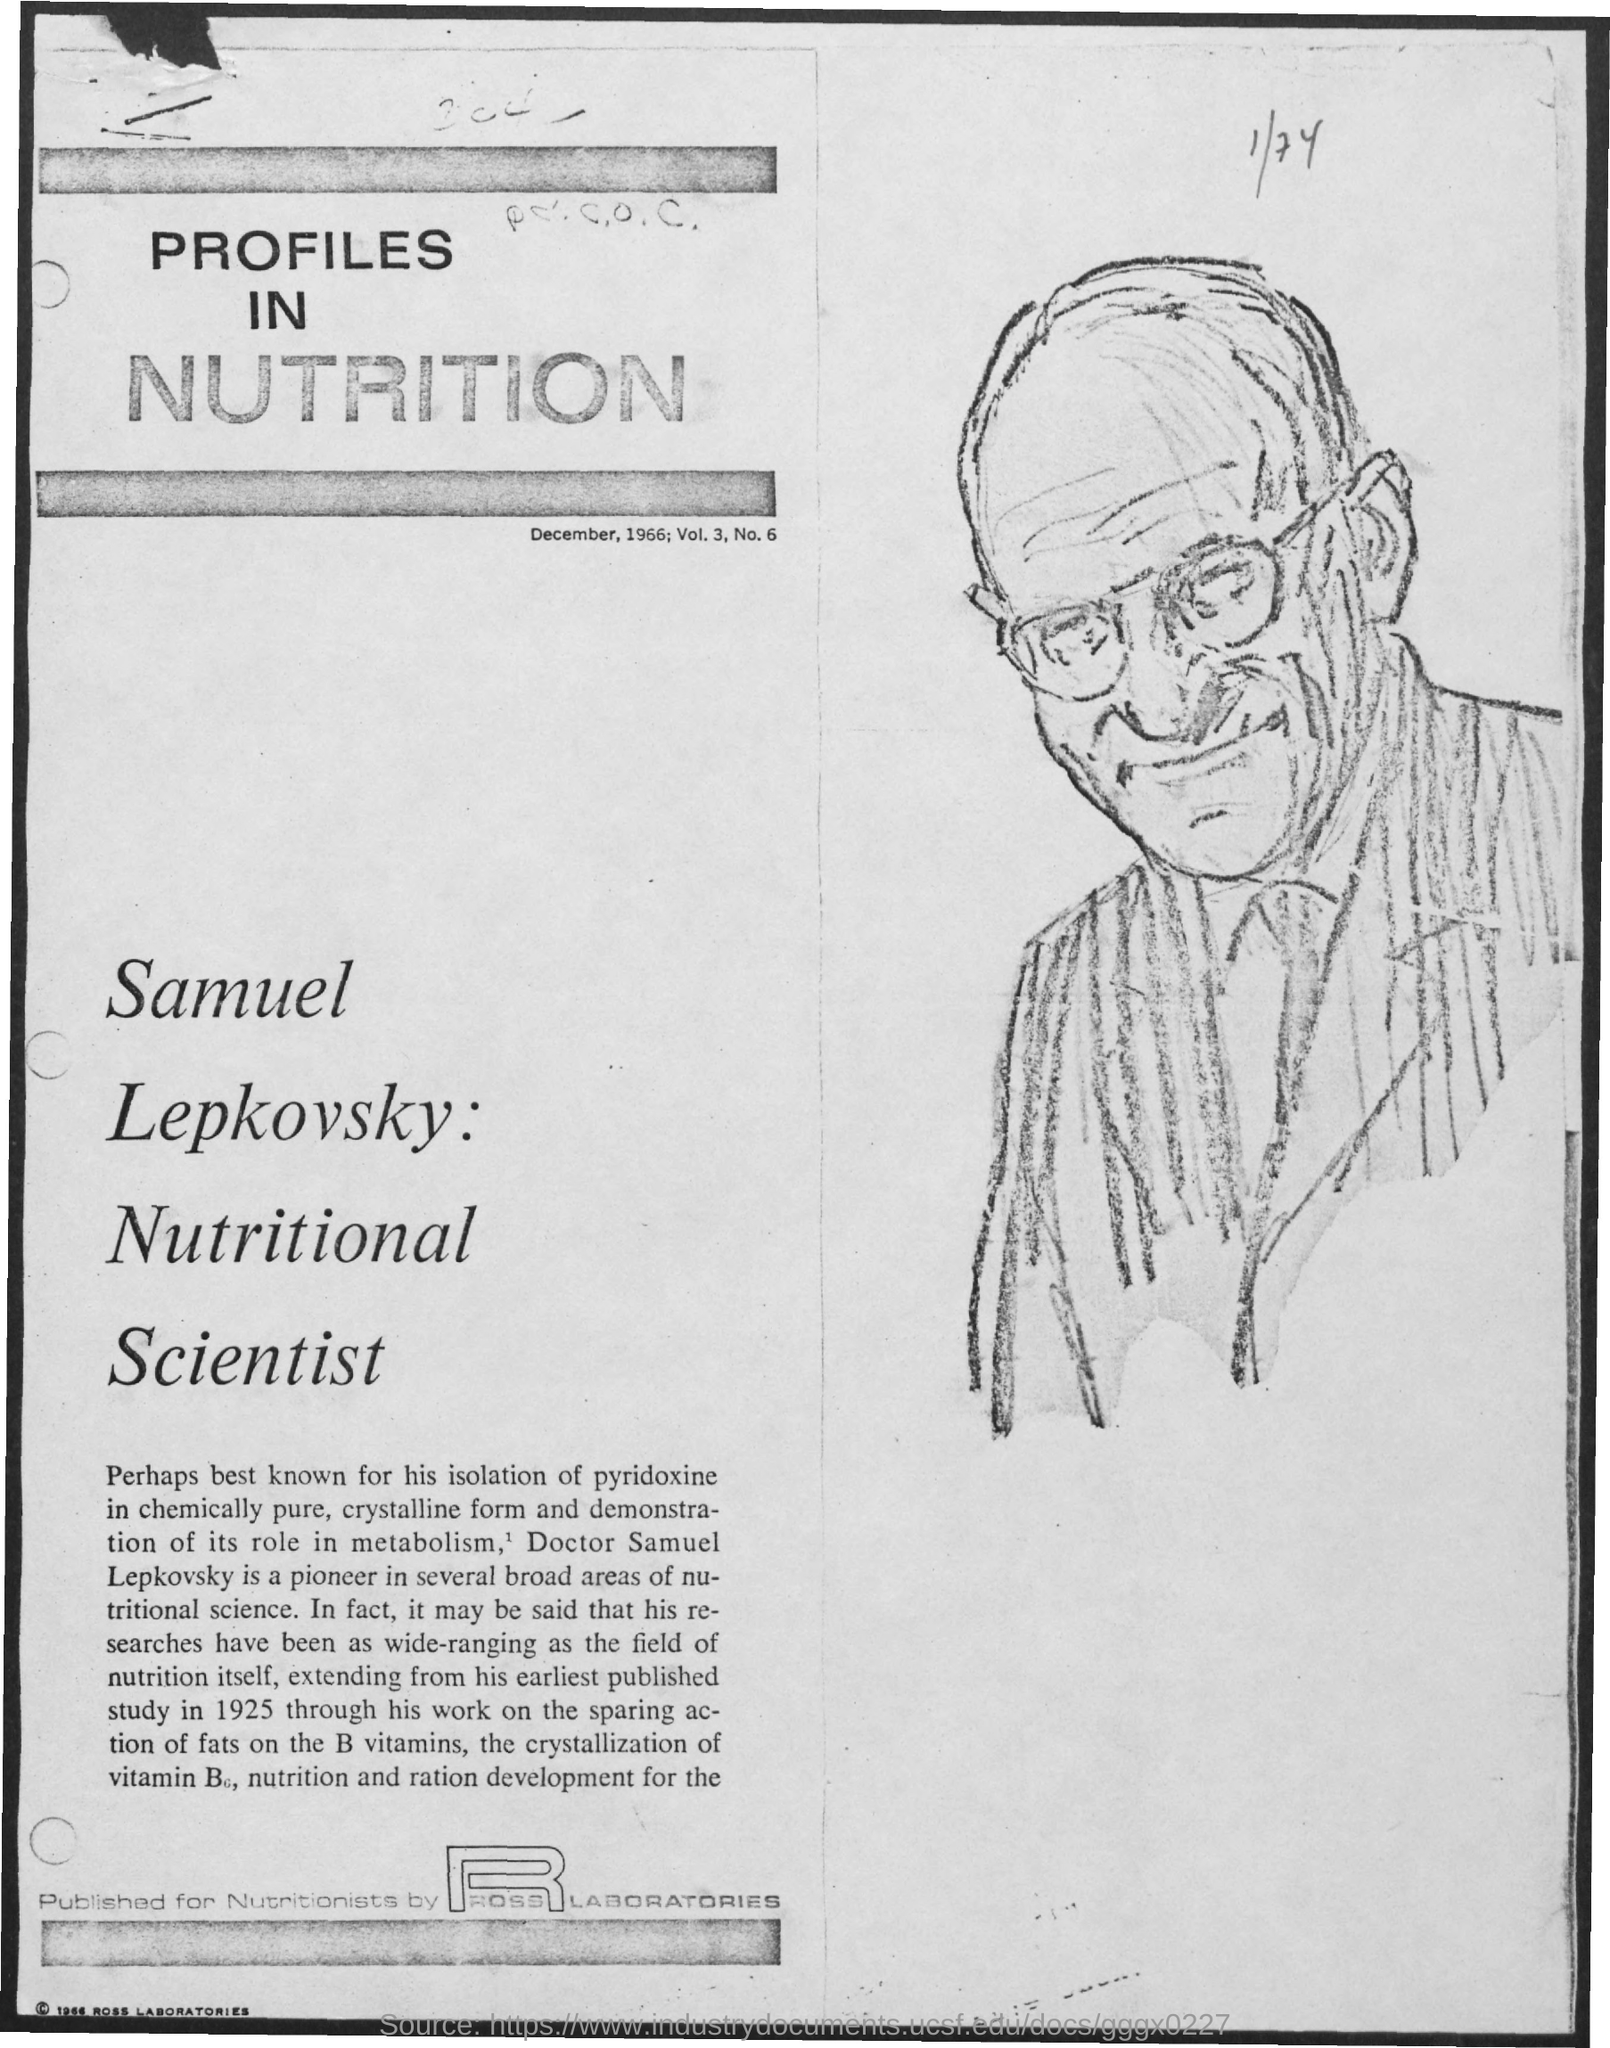What is the date on the document?
Provide a short and direct response. December, 1966. What is the Volume?
Offer a very short reply. 3. What is the Number?
Your response must be concise. 6. What is the Title of the document?
Your response must be concise. Profiles in Nutrition. 